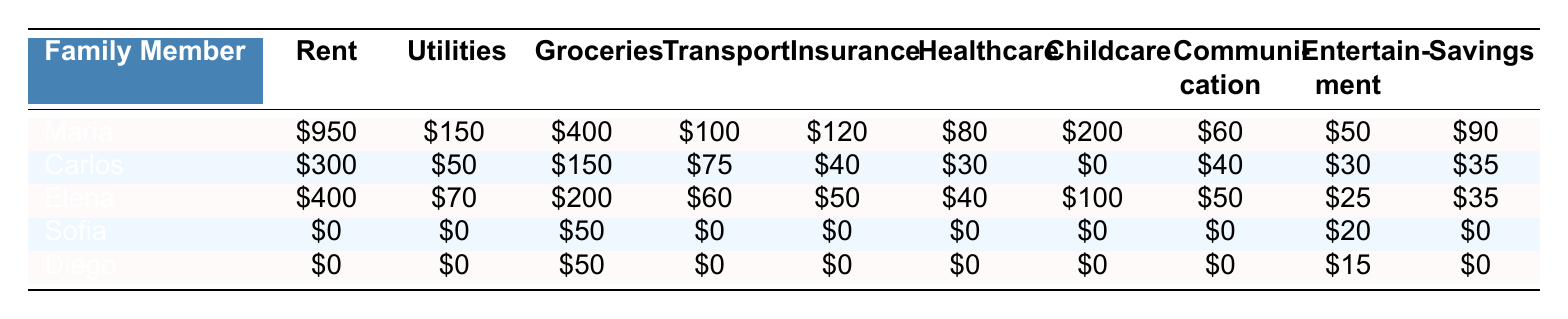What is Maria's total monthly expense on groceries? Maria's monthly grocery expense is shown in the table as \$400.
Answer: 400 How much do Carlos and Elena spend on entertainment combined? Carlos spends \$30 and Elena spends \$25 on entertainment, so their combined spending is 30 + 25 = \$55.
Answer: 55 Does Sofia have any expenses related to rent? The table shows that Sofia's rent is \$0, meaning she does not have any rent expenses.
Answer: No What is the total monthly income of the family members combined? Add the total incomes of all family members: 2200 (Maria) + 1400 (Carlos) + 1800 (Elena) + 0 (Sofia) + 0 (Diego) = \$4400.
Answer: 4400 Which family member has the highest monthly expense for childcare, and how much is it? Elena has the highest childcare expense at \$100, while others have either \$0 or less than this amount.
Answer: Elena, 100 If we add up all monthly expenses for Diego, what is the total? Diego has the following expenses: rent \$0, utilities \$0, groceries \$50, transportation \$0, insurance \$0, healthcare \$0, childcare \$0, communication \$0, entertainment \$15, totals to 0 + 0 + 50 + 0 + 0 + 0 + 0 + 0 + 15 = \$65.
Answer: 65 Is it true that Maria's combined expenses for healthcare and insurance are more than Carlos's total income? Maria has healthcare expenses of \$80 and insurance expenses of \$120, totaling 80 + 120 = \$200, while Carlos's total income is \$1400. Since \$200 < \$1400, the statement is false.
Answer: No What percentage of Maria's total income does she spend on rent? Maria spends \$950 on rent and her total income is \$2200. To find the percentage, calculate (950 / 2200) * 100 = 43.18%.
Answer: 43.18% How much more does Carlos spend on groceries compared to Diego? Carlos spends \$150 on groceries while Diego spends \$50. The difference is 150 - 50 = \$100.
Answer: 100 Which family member has the lowest total monthly expenses, and what is that amount? The table shows that Sofia's total expenses are \$50 (groceries) + \$20 (entertainment) = \$70, which is lower than any other family member.
Answer: Sofia, 70 What is the average amount spent on transportation across all family members? The transportation expenses are: Maria \$100, Carlos \$75, Elena \$60, Sofia \$0, Diego \$0. Average is (100 + 75 + 60 + 0 + 0) / 5 = 235 / 5 = \$47.
Answer: 47 